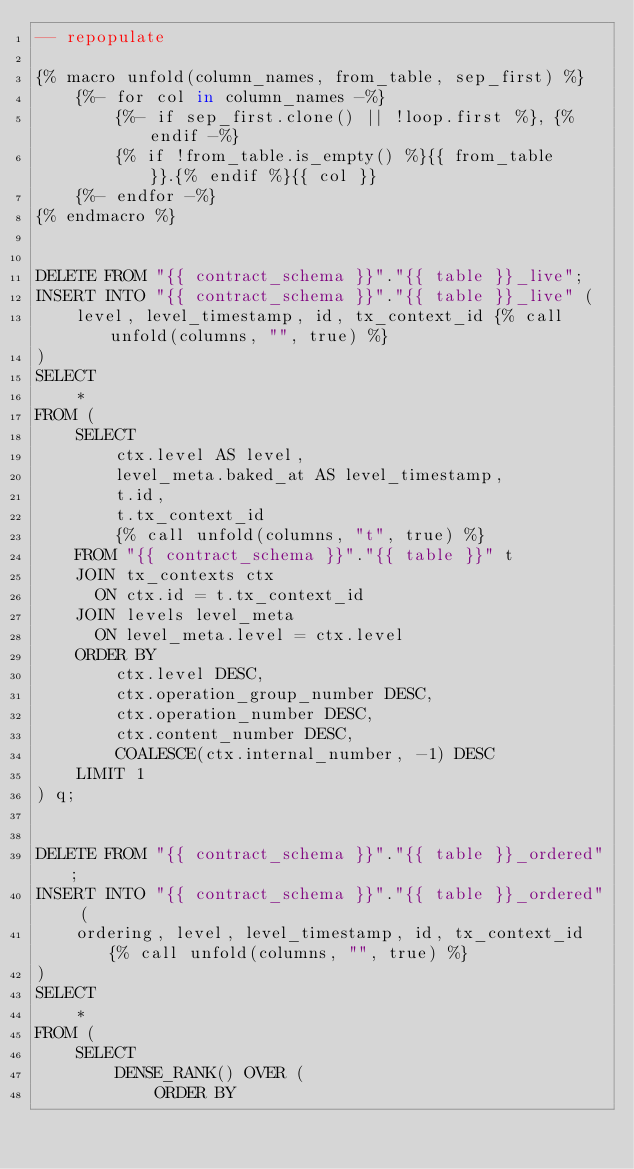<code> <loc_0><loc_0><loc_500><loc_500><_SQL_>-- repopulate

{% macro unfold(column_names, from_table, sep_first) %}
    {%- for col in column_names -%}
        {%- if sep_first.clone() || !loop.first %}, {% endif -%}
        {% if !from_table.is_empty() %}{{ from_table }}.{% endif %}{{ col }}
    {%- endfor -%}
{% endmacro %}


DELETE FROM "{{ contract_schema }}"."{{ table }}_live";
INSERT INTO "{{ contract_schema }}"."{{ table }}_live" (
    level, level_timestamp, id, tx_context_id {% call unfold(columns, "", true) %}
)
SELECT
    *
FROM (
    SELECT
        ctx.level AS level,
        level_meta.baked_at AS level_timestamp,
        t.id,
        t.tx_context_id
        {% call unfold(columns, "t", true) %}
    FROM "{{ contract_schema }}"."{{ table }}" t
    JOIN tx_contexts ctx
      ON ctx.id = t.tx_context_id
    JOIN levels level_meta
      ON level_meta.level = ctx.level
    ORDER BY
        ctx.level DESC,
        ctx.operation_group_number DESC,
        ctx.operation_number DESC,
        ctx.content_number DESC,
        COALESCE(ctx.internal_number, -1) DESC
    LIMIT 1
) q;


DELETE FROM "{{ contract_schema }}"."{{ table }}_ordered";
INSERT INTO "{{ contract_schema }}"."{{ table }}_ordered" (
    ordering, level, level_timestamp, id, tx_context_id {% call unfold(columns, "", true) %}
)
SELECT
    *
FROM (
    SELECT
        DENSE_RANK() OVER (
            ORDER BY</code> 